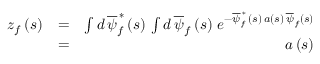<formula> <loc_0><loc_0><loc_500><loc_500>\begin{array} { r l r } { z _ { f } \left ( s \right ) } & { = } & { \int d \, \overline { \psi } _ { f } ^ { \, \ast } \left ( s \right ) \, \int d \, \overline { \psi } _ { f } \left ( s \right ) \, e ^ { - \overline { \psi } _ { f } ^ { \, \ast } \, \left ( s \right ) \, a \left ( s \right ) \, \overline { \psi } _ { f } \left ( s \right ) } } \\ & { = } & { a \left ( s \right ) } \end{array}</formula> 